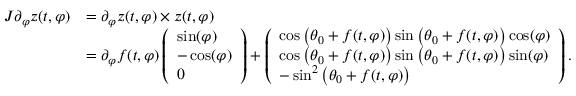<formula> <loc_0><loc_0><loc_500><loc_500>\begin{array} { r l } { J \partial _ { \varphi } z ( t , \varphi ) } & { = \partial _ { \varphi } z ( t , \varphi ) \times z ( t , \varphi ) } \\ & { = \partial _ { \varphi } f ( t , \varphi ) \left ( \begin{array} { l } { \sin ( \varphi ) } \\ { - \cos ( \varphi ) } \\ { 0 } \end{array} \right ) + \left ( \begin{array} { l } { \cos \left ( \theta _ { 0 } + f ( t , \varphi ) \right ) \sin \left ( \theta _ { 0 } + f ( t , \varphi ) \right ) \cos ( \varphi ) } \\ { \cos \left ( \theta _ { 0 } + f ( t , \varphi ) \right ) \sin \left ( \theta _ { 0 } + f ( t , \varphi ) \right ) \sin ( \varphi ) } \\ { - \sin ^ { 2 } \left ( \theta _ { 0 } + f ( t , \varphi ) \right ) } \end{array} \right ) . } \end{array}</formula> 